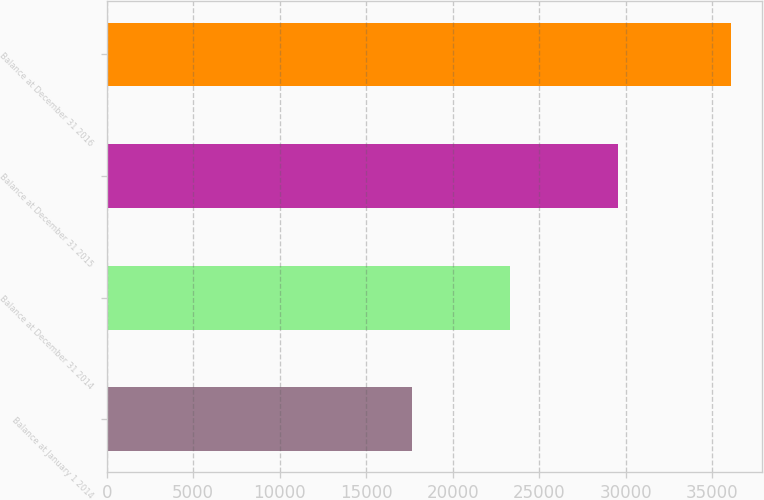Convert chart to OTSL. <chart><loc_0><loc_0><loc_500><loc_500><bar_chart><fcel>Balance at January 1 2014<fcel>Balance at December 31 2014<fcel>Balance at December 31 2015<fcel>Balance at December 31 2016<nl><fcel>17671<fcel>23298<fcel>29568<fcel>36097<nl></chart> 